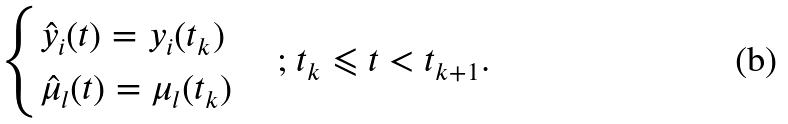Convert formula to latex. <formula><loc_0><loc_0><loc_500><loc_500>\begin{cases} { { { \hat { y } } _ { i } } ( t ) = { y _ { i } } ( { t _ { k } } ) } \\ { { { \hat { \mu } } _ { l } } ( t ) = { \mu _ { l } } ( { t _ { k } } ) } \end{cases} { \text {; } } { t _ { k } } \leqslant t < { t _ { k + 1 } } .</formula> 